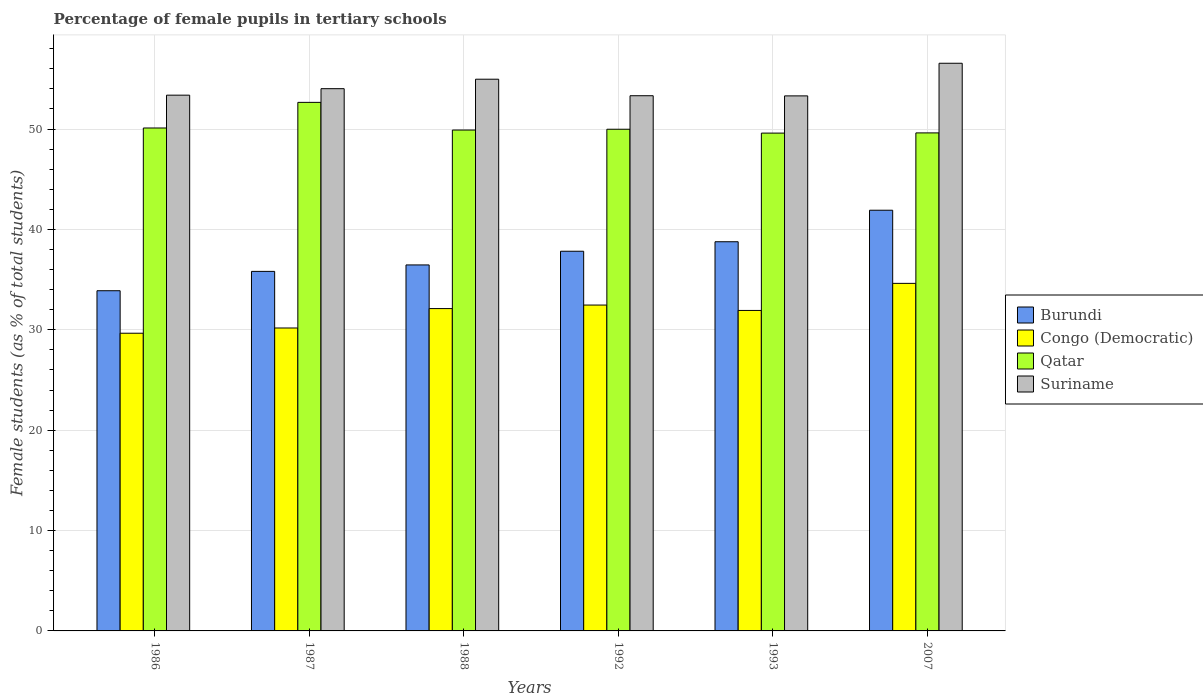How many different coloured bars are there?
Your answer should be compact. 4. How many groups of bars are there?
Your answer should be compact. 6. Are the number of bars per tick equal to the number of legend labels?
Make the answer very short. Yes. How many bars are there on the 6th tick from the right?
Your response must be concise. 4. What is the label of the 4th group of bars from the left?
Keep it short and to the point. 1992. What is the percentage of female pupils in tertiary schools in Suriname in 2007?
Your answer should be compact. 56.55. Across all years, what is the maximum percentage of female pupils in tertiary schools in Congo (Democratic)?
Your answer should be compact. 34.62. Across all years, what is the minimum percentage of female pupils in tertiary schools in Qatar?
Make the answer very short. 49.59. In which year was the percentage of female pupils in tertiary schools in Qatar maximum?
Offer a very short reply. 1987. What is the total percentage of female pupils in tertiary schools in Burundi in the graph?
Make the answer very short. 224.67. What is the difference between the percentage of female pupils in tertiary schools in Burundi in 1987 and that in 1992?
Offer a terse response. -2.01. What is the difference between the percentage of female pupils in tertiary schools in Burundi in 2007 and the percentage of female pupils in tertiary schools in Qatar in 1993?
Ensure brevity in your answer.  -7.68. What is the average percentage of female pupils in tertiary schools in Congo (Democratic) per year?
Make the answer very short. 31.83. In the year 1988, what is the difference between the percentage of female pupils in tertiary schools in Suriname and percentage of female pupils in tertiary schools in Qatar?
Offer a very short reply. 5.06. What is the ratio of the percentage of female pupils in tertiary schools in Congo (Democratic) in 1992 to that in 1993?
Your response must be concise. 1.02. What is the difference between the highest and the second highest percentage of female pupils in tertiary schools in Congo (Democratic)?
Your response must be concise. 2.16. What is the difference between the highest and the lowest percentage of female pupils in tertiary schools in Qatar?
Keep it short and to the point. 3.06. In how many years, is the percentage of female pupils in tertiary schools in Suriname greater than the average percentage of female pupils in tertiary schools in Suriname taken over all years?
Give a very brief answer. 2. Is it the case that in every year, the sum of the percentage of female pupils in tertiary schools in Burundi and percentage of female pupils in tertiary schools in Suriname is greater than the sum of percentage of female pupils in tertiary schools in Qatar and percentage of female pupils in tertiary schools in Congo (Democratic)?
Offer a very short reply. No. What does the 2nd bar from the left in 1987 represents?
Make the answer very short. Congo (Democratic). What does the 4th bar from the right in 1993 represents?
Your answer should be very brief. Burundi. What is the difference between two consecutive major ticks on the Y-axis?
Provide a succinct answer. 10. Does the graph contain any zero values?
Offer a very short reply. No. Where does the legend appear in the graph?
Give a very brief answer. Center right. How many legend labels are there?
Your answer should be compact. 4. What is the title of the graph?
Provide a succinct answer. Percentage of female pupils in tertiary schools. Does "Tonga" appear as one of the legend labels in the graph?
Offer a very short reply. No. What is the label or title of the Y-axis?
Give a very brief answer. Female students (as % of total students). What is the Female students (as % of total students) of Burundi in 1986?
Offer a terse response. 33.89. What is the Female students (as % of total students) in Congo (Democratic) in 1986?
Give a very brief answer. 29.66. What is the Female students (as % of total students) of Qatar in 1986?
Your response must be concise. 50.1. What is the Female students (as % of total students) in Suriname in 1986?
Provide a succinct answer. 53.37. What is the Female students (as % of total students) of Burundi in 1987?
Your answer should be compact. 35.82. What is the Female students (as % of total students) in Congo (Democratic) in 1987?
Give a very brief answer. 30.18. What is the Female students (as % of total students) in Qatar in 1987?
Give a very brief answer. 52.66. What is the Female students (as % of total students) of Suriname in 1987?
Give a very brief answer. 54.02. What is the Female students (as % of total students) of Burundi in 1988?
Your answer should be very brief. 36.46. What is the Female students (as % of total students) of Congo (Democratic) in 1988?
Offer a very short reply. 32.11. What is the Female students (as % of total students) of Qatar in 1988?
Make the answer very short. 49.9. What is the Female students (as % of total students) in Suriname in 1988?
Make the answer very short. 54.96. What is the Female students (as % of total students) of Burundi in 1992?
Give a very brief answer. 37.82. What is the Female students (as % of total students) in Congo (Democratic) in 1992?
Provide a short and direct response. 32.46. What is the Female students (as % of total students) of Qatar in 1992?
Keep it short and to the point. 49.98. What is the Female students (as % of total students) in Suriname in 1992?
Provide a succinct answer. 53.32. What is the Female students (as % of total students) of Burundi in 1993?
Keep it short and to the point. 38.77. What is the Female students (as % of total students) in Congo (Democratic) in 1993?
Offer a terse response. 31.93. What is the Female students (as % of total students) of Qatar in 1993?
Your answer should be compact. 49.59. What is the Female students (as % of total students) of Suriname in 1993?
Your answer should be compact. 53.3. What is the Female students (as % of total students) of Burundi in 2007?
Your response must be concise. 41.91. What is the Female students (as % of total students) of Congo (Democratic) in 2007?
Provide a short and direct response. 34.62. What is the Female students (as % of total students) of Qatar in 2007?
Make the answer very short. 49.61. What is the Female students (as % of total students) of Suriname in 2007?
Provide a short and direct response. 56.55. Across all years, what is the maximum Female students (as % of total students) in Burundi?
Offer a terse response. 41.91. Across all years, what is the maximum Female students (as % of total students) in Congo (Democratic)?
Offer a very short reply. 34.62. Across all years, what is the maximum Female students (as % of total students) in Qatar?
Give a very brief answer. 52.66. Across all years, what is the maximum Female students (as % of total students) of Suriname?
Ensure brevity in your answer.  56.55. Across all years, what is the minimum Female students (as % of total students) of Burundi?
Your response must be concise. 33.89. Across all years, what is the minimum Female students (as % of total students) in Congo (Democratic)?
Your response must be concise. 29.66. Across all years, what is the minimum Female students (as % of total students) in Qatar?
Your answer should be compact. 49.59. Across all years, what is the minimum Female students (as % of total students) in Suriname?
Make the answer very short. 53.3. What is the total Female students (as % of total students) in Burundi in the graph?
Keep it short and to the point. 224.67. What is the total Female students (as % of total students) in Congo (Democratic) in the graph?
Offer a terse response. 190.96. What is the total Female students (as % of total students) of Qatar in the graph?
Ensure brevity in your answer.  301.84. What is the total Female students (as % of total students) of Suriname in the graph?
Provide a succinct answer. 325.52. What is the difference between the Female students (as % of total students) in Burundi in 1986 and that in 1987?
Provide a short and direct response. -1.93. What is the difference between the Female students (as % of total students) in Congo (Democratic) in 1986 and that in 1987?
Keep it short and to the point. -0.52. What is the difference between the Female students (as % of total students) in Qatar in 1986 and that in 1987?
Offer a terse response. -2.55. What is the difference between the Female students (as % of total students) of Suriname in 1986 and that in 1987?
Provide a succinct answer. -0.65. What is the difference between the Female students (as % of total students) in Burundi in 1986 and that in 1988?
Keep it short and to the point. -2.57. What is the difference between the Female students (as % of total students) of Congo (Democratic) in 1986 and that in 1988?
Ensure brevity in your answer.  -2.46. What is the difference between the Female students (as % of total students) of Qatar in 1986 and that in 1988?
Your answer should be very brief. 0.2. What is the difference between the Female students (as % of total students) of Suriname in 1986 and that in 1988?
Provide a short and direct response. -1.59. What is the difference between the Female students (as % of total students) of Burundi in 1986 and that in 1992?
Your answer should be very brief. -3.93. What is the difference between the Female students (as % of total students) of Congo (Democratic) in 1986 and that in 1992?
Offer a terse response. -2.81. What is the difference between the Female students (as % of total students) of Qatar in 1986 and that in 1992?
Offer a terse response. 0.12. What is the difference between the Female students (as % of total students) in Suriname in 1986 and that in 1992?
Provide a succinct answer. 0.06. What is the difference between the Female students (as % of total students) in Burundi in 1986 and that in 1993?
Make the answer very short. -4.88. What is the difference between the Female students (as % of total students) in Congo (Democratic) in 1986 and that in 1993?
Your answer should be compact. -2.27. What is the difference between the Female students (as % of total students) of Qatar in 1986 and that in 1993?
Offer a very short reply. 0.51. What is the difference between the Female students (as % of total students) of Suriname in 1986 and that in 1993?
Give a very brief answer. 0.07. What is the difference between the Female students (as % of total students) of Burundi in 1986 and that in 2007?
Ensure brevity in your answer.  -8.02. What is the difference between the Female students (as % of total students) in Congo (Democratic) in 1986 and that in 2007?
Provide a succinct answer. -4.97. What is the difference between the Female students (as % of total students) in Qatar in 1986 and that in 2007?
Your response must be concise. 0.49. What is the difference between the Female students (as % of total students) in Suriname in 1986 and that in 2007?
Provide a short and direct response. -3.18. What is the difference between the Female students (as % of total students) in Burundi in 1987 and that in 1988?
Offer a terse response. -0.64. What is the difference between the Female students (as % of total students) in Congo (Democratic) in 1987 and that in 1988?
Make the answer very short. -1.93. What is the difference between the Female students (as % of total students) in Qatar in 1987 and that in 1988?
Offer a very short reply. 2.76. What is the difference between the Female students (as % of total students) in Suriname in 1987 and that in 1988?
Give a very brief answer. -0.94. What is the difference between the Female students (as % of total students) in Burundi in 1987 and that in 1992?
Offer a terse response. -2.01. What is the difference between the Female students (as % of total students) in Congo (Democratic) in 1987 and that in 1992?
Your answer should be very brief. -2.29. What is the difference between the Female students (as % of total students) in Qatar in 1987 and that in 1992?
Offer a terse response. 2.68. What is the difference between the Female students (as % of total students) of Suriname in 1987 and that in 1992?
Make the answer very short. 0.7. What is the difference between the Female students (as % of total students) of Burundi in 1987 and that in 1993?
Your answer should be very brief. -2.95. What is the difference between the Female students (as % of total students) in Congo (Democratic) in 1987 and that in 1993?
Provide a succinct answer. -1.75. What is the difference between the Female students (as % of total students) in Qatar in 1987 and that in 1993?
Provide a short and direct response. 3.06. What is the difference between the Female students (as % of total students) of Suriname in 1987 and that in 1993?
Offer a very short reply. 0.72. What is the difference between the Female students (as % of total students) of Burundi in 1987 and that in 2007?
Offer a terse response. -6.09. What is the difference between the Female students (as % of total students) in Congo (Democratic) in 1987 and that in 2007?
Give a very brief answer. -4.45. What is the difference between the Female students (as % of total students) in Qatar in 1987 and that in 2007?
Your response must be concise. 3.04. What is the difference between the Female students (as % of total students) of Suriname in 1987 and that in 2007?
Offer a very short reply. -2.53. What is the difference between the Female students (as % of total students) of Burundi in 1988 and that in 1992?
Provide a succinct answer. -1.36. What is the difference between the Female students (as % of total students) of Congo (Democratic) in 1988 and that in 1992?
Make the answer very short. -0.35. What is the difference between the Female students (as % of total students) of Qatar in 1988 and that in 1992?
Offer a terse response. -0.08. What is the difference between the Female students (as % of total students) in Suriname in 1988 and that in 1992?
Ensure brevity in your answer.  1.65. What is the difference between the Female students (as % of total students) in Burundi in 1988 and that in 1993?
Provide a succinct answer. -2.31. What is the difference between the Female students (as % of total students) of Congo (Democratic) in 1988 and that in 1993?
Your response must be concise. 0.19. What is the difference between the Female students (as % of total students) of Qatar in 1988 and that in 1993?
Provide a succinct answer. 0.31. What is the difference between the Female students (as % of total students) in Suriname in 1988 and that in 1993?
Offer a terse response. 1.66. What is the difference between the Female students (as % of total students) of Burundi in 1988 and that in 2007?
Ensure brevity in your answer.  -5.45. What is the difference between the Female students (as % of total students) of Congo (Democratic) in 1988 and that in 2007?
Offer a very short reply. -2.51. What is the difference between the Female students (as % of total students) of Qatar in 1988 and that in 2007?
Your answer should be very brief. 0.28. What is the difference between the Female students (as % of total students) in Suriname in 1988 and that in 2007?
Ensure brevity in your answer.  -1.59. What is the difference between the Female students (as % of total students) in Burundi in 1992 and that in 1993?
Provide a succinct answer. -0.95. What is the difference between the Female students (as % of total students) of Congo (Democratic) in 1992 and that in 1993?
Give a very brief answer. 0.54. What is the difference between the Female students (as % of total students) of Qatar in 1992 and that in 1993?
Ensure brevity in your answer.  0.38. What is the difference between the Female students (as % of total students) in Suriname in 1992 and that in 1993?
Provide a short and direct response. 0.01. What is the difference between the Female students (as % of total students) in Burundi in 1992 and that in 2007?
Provide a short and direct response. -4.09. What is the difference between the Female students (as % of total students) of Congo (Democratic) in 1992 and that in 2007?
Keep it short and to the point. -2.16. What is the difference between the Female students (as % of total students) in Qatar in 1992 and that in 2007?
Offer a very short reply. 0.36. What is the difference between the Female students (as % of total students) in Suriname in 1992 and that in 2007?
Give a very brief answer. -3.23. What is the difference between the Female students (as % of total students) of Burundi in 1993 and that in 2007?
Your answer should be compact. -3.14. What is the difference between the Female students (as % of total students) of Congo (Democratic) in 1993 and that in 2007?
Your answer should be very brief. -2.7. What is the difference between the Female students (as % of total students) in Qatar in 1993 and that in 2007?
Offer a terse response. -0.02. What is the difference between the Female students (as % of total students) of Suriname in 1993 and that in 2007?
Offer a very short reply. -3.25. What is the difference between the Female students (as % of total students) in Burundi in 1986 and the Female students (as % of total students) in Congo (Democratic) in 1987?
Provide a succinct answer. 3.71. What is the difference between the Female students (as % of total students) in Burundi in 1986 and the Female students (as % of total students) in Qatar in 1987?
Offer a very short reply. -18.76. What is the difference between the Female students (as % of total students) of Burundi in 1986 and the Female students (as % of total students) of Suriname in 1987?
Make the answer very short. -20.13. What is the difference between the Female students (as % of total students) in Congo (Democratic) in 1986 and the Female students (as % of total students) in Qatar in 1987?
Make the answer very short. -23. What is the difference between the Female students (as % of total students) in Congo (Democratic) in 1986 and the Female students (as % of total students) in Suriname in 1987?
Give a very brief answer. -24.36. What is the difference between the Female students (as % of total students) in Qatar in 1986 and the Female students (as % of total students) in Suriname in 1987?
Give a very brief answer. -3.92. What is the difference between the Female students (as % of total students) in Burundi in 1986 and the Female students (as % of total students) in Congo (Democratic) in 1988?
Make the answer very short. 1.78. What is the difference between the Female students (as % of total students) of Burundi in 1986 and the Female students (as % of total students) of Qatar in 1988?
Your answer should be compact. -16.01. What is the difference between the Female students (as % of total students) in Burundi in 1986 and the Female students (as % of total students) in Suriname in 1988?
Your response must be concise. -21.07. What is the difference between the Female students (as % of total students) of Congo (Democratic) in 1986 and the Female students (as % of total students) of Qatar in 1988?
Ensure brevity in your answer.  -20.24. What is the difference between the Female students (as % of total students) in Congo (Democratic) in 1986 and the Female students (as % of total students) in Suriname in 1988?
Provide a short and direct response. -25.31. What is the difference between the Female students (as % of total students) of Qatar in 1986 and the Female students (as % of total students) of Suriname in 1988?
Your answer should be compact. -4.86. What is the difference between the Female students (as % of total students) in Burundi in 1986 and the Female students (as % of total students) in Congo (Democratic) in 1992?
Offer a terse response. 1.43. What is the difference between the Female students (as % of total students) in Burundi in 1986 and the Female students (as % of total students) in Qatar in 1992?
Provide a short and direct response. -16.09. What is the difference between the Female students (as % of total students) of Burundi in 1986 and the Female students (as % of total students) of Suriname in 1992?
Give a very brief answer. -19.43. What is the difference between the Female students (as % of total students) in Congo (Democratic) in 1986 and the Female students (as % of total students) in Qatar in 1992?
Provide a short and direct response. -20.32. What is the difference between the Female students (as % of total students) of Congo (Democratic) in 1986 and the Female students (as % of total students) of Suriname in 1992?
Your response must be concise. -23.66. What is the difference between the Female students (as % of total students) of Qatar in 1986 and the Female students (as % of total students) of Suriname in 1992?
Give a very brief answer. -3.21. What is the difference between the Female students (as % of total students) in Burundi in 1986 and the Female students (as % of total students) in Congo (Democratic) in 1993?
Your answer should be very brief. 1.96. What is the difference between the Female students (as % of total students) in Burundi in 1986 and the Female students (as % of total students) in Qatar in 1993?
Offer a terse response. -15.7. What is the difference between the Female students (as % of total students) of Burundi in 1986 and the Female students (as % of total students) of Suriname in 1993?
Ensure brevity in your answer.  -19.41. What is the difference between the Female students (as % of total students) in Congo (Democratic) in 1986 and the Female students (as % of total students) in Qatar in 1993?
Your response must be concise. -19.94. What is the difference between the Female students (as % of total students) in Congo (Democratic) in 1986 and the Female students (as % of total students) in Suriname in 1993?
Provide a short and direct response. -23.64. What is the difference between the Female students (as % of total students) of Qatar in 1986 and the Female students (as % of total students) of Suriname in 1993?
Your response must be concise. -3.2. What is the difference between the Female students (as % of total students) of Burundi in 1986 and the Female students (as % of total students) of Congo (Democratic) in 2007?
Make the answer very short. -0.73. What is the difference between the Female students (as % of total students) of Burundi in 1986 and the Female students (as % of total students) of Qatar in 2007?
Make the answer very short. -15.72. What is the difference between the Female students (as % of total students) of Burundi in 1986 and the Female students (as % of total students) of Suriname in 2007?
Provide a short and direct response. -22.66. What is the difference between the Female students (as % of total students) in Congo (Democratic) in 1986 and the Female students (as % of total students) in Qatar in 2007?
Ensure brevity in your answer.  -19.96. What is the difference between the Female students (as % of total students) in Congo (Democratic) in 1986 and the Female students (as % of total students) in Suriname in 2007?
Give a very brief answer. -26.89. What is the difference between the Female students (as % of total students) of Qatar in 1986 and the Female students (as % of total students) of Suriname in 2007?
Keep it short and to the point. -6.45. What is the difference between the Female students (as % of total students) in Burundi in 1987 and the Female students (as % of total students) in Congo (Democratic) in 1988?
Provide a succinct answer. 3.71. What is the difference between the Female students (as % of total students) of Burundi in 1987 and the Female students (as % of total students) of Qatar in 1988?
Ensure brevity in your answer.  -14.08. What is the difference between the Female students (as % of total students) of Burundi in 1987 and the Female students (as % of total students) of Suriname in 1988?
Give a very brief answer. -19.14. What is the difference between the Female students (as % of total students) in Congo (Democratic) in 1987 and the Female students (as % of total students) in Qatar in 1988?
Provide a short and direct response. -19.72. What is the difference between the Female students (as % of total students) in Congo (Democratic) in 1987 and the Female students (as % of total students) in Suriname in 1988?
Offer a terse response. -24.79. What is the difference between the Female students (as % of total students) of Qatar in 1987 and the Female students (as % of total students) of Suriname in 1988?
Keep it short and to the point. -2.31. What is the difference between the Female students (as % of total students) in Burundi in 1987 and the Female students (as % of total students) in Congo (Democratic) in 1992?
Offer a terse response. 3.36. What is the difference between the Female students (as % of total students) in Burundi in 1987 and the Female students (as % of total students) in Qatar in 1992?
Provide a succinct answer. -14.16. What is the difference between the Female students (as % of total students) in Burundi in 1987 and the Female students (as % of total students) in Suriname in 1992?
Provide a short and direct response. -17.5. What is the difference between the Female students (as % of total students) of Congo (Democratic) in 1987 and the Female students (as % of total students) of Qatar in 1992?
Ensure brevity in your answer.  -19.8. What is the difference between the Female students (as % of total students) of Congo (Democratic) in 1987 and the Female students (as % of total students) of Suriname in 1992?
Offer a very short reply. -23.14. What is the difference between the Female students (as % of total students) of Qatar in 1987 and the Female students (as % of total students) of Suriname in 1992?
Make the answer very short. -0.66. What is the difference between the Female students (as % of total students) in Burundi in 1987 and the Female students (as % of total students) in Congo (Democratic) in 1993?
Make the answer very short. 3.89. What is the difference between the Female students (as % of total students) of Burundi in 1987 and the Female students (as % of total students) of Qatar in 1993?
Provide a short and direct response. -13.77. What is the difference between the Female students (as % of total students) in Burundi in 1987 and the Female students (as % of total students) in Suriname in 1993?
Provide a succinct answer. -17.48. What is the difference between the Female students (as % of total students) in Congo (Democratic) in 1987 and the Female students (as % of total students) in Qatar in 1993?
Your response must be concise. -19.42. What is the difference between the Female students (as % of total students) in Congo (Democratic) in 1987 and the Female students (as % of total students) in Suriname in 1993?
Make the answer very short. -23.12. What is the difference between the Female students (as % of total students) in Qatar in 1987 and the Female students (as % of total students) in Suriname in 1993?
Ensure brevity in your answer.  -0.65. What is the difference between the Female students (as % of total students) in Burundi in 1987 and the Female students (as % of total students) in Congo (Democratic) in 2007?
Ensure brevity in your answer.  1.2. What is the difference between the Female students (as % of total students) in Burundi in 1987 and the Female students (as % of total students) in Qatar in 2007?
Ensure brevity in your answer.  -13.8. What is the difference between the Female students (as % of total students) in Burundi in 1987 and the Female students (as % of total students) in Suriname in 2007?
Ensure brevity in your answer.  -20.73. What is the difference between the Female students (as % of total students) in Congo (Democratic) in 1987 and the Female students (as % of total students) in Qatar in 2007?
Provide a short and direct response. -19.44. What is the difference between the Female students (as % of total students) of Congo (Democratic) in 1987 and the Female students (as % of total students) of Suriname in 2007?
Provide a short and direct response. -26.37. What is the difference between the Female students (as % of total students) of Qatar in 1987 and the Female students (as % of total students) of Suriname in 2007?
Your answer should be compact. -3.9. What is the difference between the Female students (as % of total students) of Burundi in 1988 and the Female students (as % of total students) of Congo (Democratic) in 1992?
Offer a very short reply. 4. What is the difference between the Female students (as % of total students) of Burundi in 1988 and the Female students (as % of total students) of Qatar in 1992?
Ensure brevity in your answer.  -13.52. What is the difference between the Female students (as % of total students) in Burundi in 1988 and the Female students (as % of total students) in Suriname in 1992?
Provide a short and direct response. -16.86. What is the difference between the Female students (as % of total students) in Congo (Democratic) in 1988 and the Female students (as % of total students) in Qatar in 1992?
Your answer should be compact. -17.87. What is the difference between the Female students (as % of total students) in Congo (Democratic) in 1988 and the Female students (as % of total students) in Suriname in 1992?
Your answer should be compact. -21.2. What is the difference between the Female students (as % of total students) in Qatar in 1988 and the Female students (as % of total students) in Suriname in 1992?
Ensure brevity in your answer.  -3.42. What is the difference between the Female students (as % of total students) in Burundi in 1988 and the Female students (as % of total students) in Congo (Democratic) in 1993?
Provide a succinct answer. 4.53. What is the difference between the Female students (as % of total students) of Burundi in 1988 and the Female students (as % of total students) of Qatar in 1993?
Your answer should be very brief. -13.13. What is the difference between the Female students (as % of total students) in Burundi in 1988 and the Female students (as % of total students) in Suriname in 1993?
Your answer should be very brief. -16.84. What is the difference between the Female students (as % of total students) in Congo (Democratic) in 1988 and the Female students (as % of total students) in Qatar in 1993?
Provide a succinct answer. -17.48. What is the difference between the Female students (as % of total students) in Congo (Democratic) in 1988 and the Female students (as % of total students) in Suriname in 1993?
Provide a succinct answer. -21.19. What is the difference between the Female students (as % of total students) in Qatar in 1988 and the Female students (as % of total students) in Suriname in 1993?
Give a very brief answer. -3.4. What is the difference between the Female students (as % of total students) of Burundi in 1988 and the Female students (as % of total students) of Congo (Democratic) in 2007?
Your answer should be compact. 1.84. What is the difference between the Female students (as % of total students) of Burundi in 1988 and the Female students (as % of total students) of Qatar in 2007?
Provide a short and direct response. -13.15. What is the difference between the Female students (as % of total students) in Burundi in 1988 and the Female students (as % of total students) in Suriname in 2007?
Give a very brief answer. -20.09. What is the difference between the Female students (as % of total students) of Congo (Democratic) in 1988 and the Female students (as % of total students) of Qatar in 2007?
Make the answer very short. -17.5. What is the difference between the Female students (as % of total students) in Congo (Democratic) in 1988 and the Female students (as % of total students) in Suriname in 2007?
Your answer should be very brief. -24.44. What is the difference between the Female students (as % of total students) in Qatar in 1988 and the Female students (as % of total students) in Suriname in 2007?
Offer a terse response. -6.65. What is the difference between the Female students (as % of total students) of Burundi in 1992 and the Female students (as % of total students) of Congo (Democratic) in 1993?
Make the answer very short. 5.9. What is the difference between the Female students (as % of total students) in Burundi in 1992 and the Female students (as % of total students) in Qatar in 1993?
Your answer should be compact. -11.77. What is the difference between the Female students (as % of total students) of Burundi in 1992 and the Female students (as % of total students) of Suriname in 1993?
Ensure brevity in your answer.  -15.48. What is the difference between the Female students (as % of total students) in Congo (Democratic) in 1992 and the Female students (as % of total students) in Qatar in 1993?
Your answer should be compact. -17.13. What is the difference between the Female students (as % of total students) in Congo (Democratic) in 1992 and the Female students (as % of total students) in Suriname in 1993?
Provide a succinct answer. -20.84. What is the difference between the Female students (as % of total students) in Qatar in 1992 and the Female students (as % of total students) in Suriname in 1993?
Offer a very short reply. -3.32. What is the difference between the Female students (as % of total students) of Burundi in 1992 and the Female students (as % of total students) of Congo (Democratic) in 2007?
Keep it short and to the point. 3.2. What is the difference between the Female students (as % of total students) in Burundi in 1992 and the Female students (as % of total students) in Qatar in 2007?
Provide a succinct answer. -11.79. What is the difference between the Female students (as % of total students) of Burundi in 1992 and the Female students (as % of total students) of Suriname in 2007?
Make the answer very short. -18.73. What is the difference between the Female students (as % of total students) in Congo (Democratic) in 1992 and the Female students (as % of total students) in Qatar in 2007?
Give a very brief answer. -17.15. What is the difference between the Female students (as % of total students) in Congo (Democratic) in 1992 and the Female students (as % of total students) in Suriname in 2007?
Make the answer very short. -24.09. What is the difference between the Female students (as % of total students) in Qatar in 1992 and the Female students (as % of total students) in Suriname in 2007?
Give a very brief answer. -6.57. What is the difference between the Female students (as % of total students) in Burundi in 1993 and the Female students (as % of total students) in Congo (Democratic) in 2007?
Provide a succinct answer. 4.15. What is the difference between the Female students (as % of total students) of Burundi in 1993 and the Female students (as % of total students) of Qatar in 2007?
Ensure brevity in your answer.  -10.84. What is the difference between the Female students (as % of total students) of Burundi in 1993 and the Female students (as % of total students) of Suriname in 2007?
Ensure brevity in your answer.  -17.78. What is the difference between the Female students (as % of total students) of Congo (Democratic) in 1993 and the Female students (as % of total students) of Qatar in 2007?
Provide a short and direct response. -17.69. What is the difference between the Female students (as % of total students) in Congo (Democratic) in 1993 and the Female students (as % of total students) in Suriname in 2007?
Your response must be concise. -24.62. What is the difference between the Female students (as % of total students) in Qatar in 1993 and the Female students (as % of total students) in Suriname in 2007?
Offer a very short reply. -6.96. What is the average Female students (as % of total students) in Burundi per year?
Keep it short and to the point. 37.45. What is the average Female students (as % of total students) in Congo (Democratic) per year?
Your response must be concise. 31.83. What is the average Female students (as % of total students) of Qatar per year?
Offer a very short reply. 50.31. What is the average Female students (as % of total students) of Suriname per year?
Offer a terse response. 54.25. In the year 1986, what is the difference between the Female students (as % of total students) in Burundi and Female students (as % of total students) in Congo (Democratic)?
Make the answer very short. 4.23. In the year 1986, what is the difference between the Female students (as % of total students) in Burundi and Female students (as % of total students) in Qatar?
Offer a terse response. -16.21. In the year 1986, what is the difference between the Female students (as % of total students) in Burundi and Female students (as % of total students) in Suriname?
Provide a succinct answer. -19.48. In the year 1986, what is the difference between the Female students (as % of total students) in Congo (Democratic) and Female students (as % of total students) in Qatar?
Ensure brevity in your answer.  -20.45. In the year 1986, what is the difference between the Female students (as % of total students) in Congo (Democratic) and Female students (as % of total students) in Suriname?
Your answer should be compact. -23.72. In the year 1986, what is the difference between the Female students (as % of total students) of Qatar and Female students (as % of total students) of Suriname?
Make the answer very short. -3.27. In the year 1987, what is the difference between the Female students (as % of total students) in Burundi and Female students (as % of total students) in Congo (Democratic)?
Provide a succinct answer. 5.64. In the year 1987, what is the difference between the Female students (as % of total students) in Burundi and Female students (as % of total students) in Qatar?
Make the answer very short. -16.84. In the year 1987, what is the difference between the Female students (as % of total students) of Burundi and Female students (as % of total students) of Suriname?
Keep it short and to the point. -18.2. In the year 1987, what is the difference between the Female students (as % of total students) in Congo (Democratic) and Female students (as % of total students) in Qatar?
Provide a succinct answer. -22.48. In the year 1987, what is the difference between the Female students (as % of total students) in Congo (Democratic) and Female students (as % of total students) in Suriname?
Offer a very short reply. -23.84. In the year 1987, what is the difference between the Female students (as % of total students) in Qatar and Female students (as % of total students) in Suriname?
Keep it short and to the point. -1.36. In the year 1988, what is the difference between the Female students (as % of total students) in Burundi and Female students (as % of total students) in Congo (Democratic)?
Ensure brevity in your answer.  4.35. In the year 1988, what is the difference between the Female students (as % of total students) of Burundi and Female students (as % of total students) of Qatar?
Provide a succinct answer. -13.44. In the year 1988, what is the difference between the Female students (as % of total students) in Burundi and Female students (as % of total students) in Suriname?
Your answer should be very brief. -18.5. In the year 1988, what is the difference between the Female students (as % of total students) in Congo (Democratic) and Female students (as % of total students) in Qatar?
Your answer should be very brief. -17.79. In the year 1988, what is the difference between the Female students (as % of total students) in Congo (Democratic) and Female students (as % of total students) in Suriname?
Ensure brevity in your answer.  -22.85. In the year 1988, what is the difference between the Female students (as % of total students) in Qatar and Female students (as % of total students) in Suriname?
Provide a short and direct response. -5.06. In the year 1992, what is the difference between the Female students (as % of total students) of Burundi and Female students (as % of total students) of Congo (Democratic)?
Offer a terse response. 5.36. In the year 1992, what is the difference between the Female students (as % of total students) of Burundi and Female students (as % of total students) of Qatar?
Your answer should be very brief. -12.15. In the year 1992, what is the difference between the Female students (as % of total students) in Burundi and Female students (as % of total students) in Suriname?
Provide a succinct answer. -15.49. In the year 1992, what is the difference between the Female students (as % of total students) in Congo (Democratic) and Female students (as % of total students) in Qatar?
Offer a terse response. -17.51. In the year 1992, what is the difference between the Female students (as % of total students) of Congo (Democratic) and Female students (as % of total students) of Suriname?
Ensure brevity in your answer.  -20.85. In the year 1992, what is the difference between the Female students (as % of total students) of Qatar and Female students (as % of total students) of Suriname?
Provide a succinct answer. -3.34. In the year 1993, what is the difference between the Female students (as % of total students) in Burundi and Female students (as % of total students) in Congo (Democratic)?
Offer a terse response. 6.84. In the year 1993, what is the difference between the Female students (as % of total students) in Burundi and Female students (as % of total students) in Qatar?
Offer a terse response. -10.82. In the year 1993, what is the difference between the Female students (as % of total students) in Burundi and Female students (as % of total students) in Suriname?
Ensure brevity in your answer.  -14.53. In the year 1993, what is the difference between the Female students (as % of total students) in Congo (Democratic) and Female students (as % of total students) in Qatar?
Offer a terse response. -17.67. In the year 1993, what is the difference between the Female students (as % of total students) of Congo (Democratic) and Female students (as % of total students) of Suriname?
Your answer should be very brief. -21.37. In the year 1993, what is the difference between the Female students (as % of total students) in Qatar and Female students (as % of total students) in Suriname?
Your response must be concise. -3.71. In the year 2007, what is the difference between the Female students (as % of total students) in Burundi and Female students (as % of total students) in Congo (Democratic)?
Make the answer very short. 7.29. In the year 2007, what is the difference between the Female students (as % of total students) of Burundi and Female students (as % of total students) of Qatar?
Offer a very short reply. -7.7. In the year 2007, what is the difference between the Female students (as % of total students) of Burundi and Female students (as % of total students) of Suriname?
Give a very brief answer. -14.64. In the year 2007, what is the difference between the Female students (as % of total students) in Congo (Democratic) and Female students (as % of total students) in Qatar?
Offer a terse response. -14.99. In the year 2007, what is the difference between the Female students (as % of total students) in Congo (Democratic) and Female students (as % of total students) in Suriname?
Keep it short and to the point. -21.93. In the year 2007, what is the difference between the Female students (as % of total students) in Qatar and Female students (as % of total students) in Suriname?
Your answer should be compact. -6.94. What is the ratio of the Female students (as % of total students) of Burundi in 1986 to that in 1987?
Make the answer very short. 0.95. What is the ratio of the Female students (as % of total students) of Congo (Democratic) in 1986 to that in 1987?
Your answer should be very brief. 0.98. What is the ratio of the Female students (as % of total students) of Qatar in 1986 to that in 1987?
Provide a short and direct response. 0.95. What is the ratio of the Female students (as % of total students) in Burundi in 1986 to that in 1988?
Offer a terse response. 0.93. What is the ratio of the Female students (as % of total students) in Congo (Democratic) in 1986 to that in 1988?
Give a very brief answer. 0.92. What is the ratio of the Female students (as % of total students) in Suriname in 1986 to that in 1988?
Your answer should be very brief. 0.97. What is the ratio of the Female students (as % of total students) in Burundi in 1986 to that in 1992?
Provide a short and direct response. 0.9. What is the ratio of the Female students (as % of total students) of Congo (Democratic) in 1986 to that in 1992?
Make the answer very short. 0.91. What is the ratio of the Female students (as % of total students) in Burundi in 1986 to that in 1993?
Give a very brief answer. 0.87. What is the ratio of the Female students (as % of total students) in Congo (Democratic) in 1986 to that in 1993?
Keep it short and to the point. 0.93. What is the ratio of the Female students (as % of total students) of Qatar in 1986 to that in 1993?
Your response must be concise. 1.01. What is the ratio of the Female students (as % of total students) of Burundi in 1986 to that in 2007?
Your answer should be compact. 0.81. What is the ratio of the Female students (as % of total students) of Congo (Democratic) in 1986 to that in 2007?
Your answer should be very brief. 0.86. What is the ratio of the Female students (as % of total students) of Qatar in 1986 to that in 2007?
Your answer should be very brief. 1.01. What is the ratio of the Female students (as % of total students) in Suriname in 1986 to that in 2007?
Offer a very short reply. 0.94. What is the ratio of the Female students (as % of total students) in Burundi in 1987 to that in 1988?
Keep it short and to the point. 0.98. What is the ratio of the Female students (as % of total students) in Congo (Democratic) in 1987 to that in 1988?
Your answer should be compact. 0.94. What is the ratio of the Female students (as % of total students) in Qatar in 1987 to that in 1988?
Provide a succinct answer. 1.06. What is the ratio of the Female students (as % of total students) in Suriname in 1987 to that in 1988?
Ensure brevity in your answer.  0.98. What is the ratio of the Female students (as % of total students) of Burundi in 1987 to that in 1992?
Give a very brief answer. 0.95. What is the ratio of the Female students (as % of total students) of Congo (Democratic) in 1987 to that in 1992?
Keep it short and to the point. 0.93. What is the ratio of the Female students (as % of total students) of Qatar in 1987 to that in 1992?
Provide a short and direct response. 1.05. What is the ratio of the Female students (as % of total students) of Suriname in 1987 to that in 1992?
Provide a short and direct response. 1.01. What is the ratio of the Female students (as % of total students) in Burundi in 1987 to that in 1993?
Provide a succinct answer. 0.92. What is the ratio of the Female students (as % of total students) of Congo (Democratic) in 1987 to that in 1993?
Provide a succinct answer. 0.95. What is the ratio of the Female students (as % of total students) in Qatar in 1987 to that in 1993?
Offer a terse response. 1.06. What is the ratio of the Female students (as % of total students) in Suriname in 1987 to that in 1993?
Your response must be concise. 1.01. What is the ratio of the Female students (as % of total students) in Burundi in 1987 to that in 2007?
Your answer should be very brief. 0.85. What is the ratio of the Female students (as % of total students) of Congo (Democratic) in 1987 to that in 2007?
Your answer should be compact. 0.87. What is the ratio of the Female students (as % of total students) in Qatar in 1987 to that in 2007?
Keep it short and to the point. 1.06. What is the ratio of the Female students (as % of total students) of Suriname in 1987 to that in 2007?
Offer a very short reply. 0.96. What is the ratio of the Female students (as % of total students) in Burundi in 1988 to that in 1992?
Make the answer very short. 0.96. What is the ratio of the Female students (as % of total students) of Suriname in 1988 to that in 1992?
Your response must be concise. 1.03. What is the ratio of the Female students (as % of total students) of Burundi in 1988 to that in 1993?
Offer a very short reply. 0.94. What is the ratio of the Female students (as % of total students) in Congo (Democratic) in 1988 to that in 1993?
Keep it short and to the point. 1.01. What is the ratio of the Female students (as % of total students) of Suriname in 1988 to that in 1993?
Provide a short and direct response. 1.03. What is the ratio of the Female students (as % of total students) in Burundi in 1988 to that in 2007?
Offer a terse response. 0.87. What is the ratio of the Female students (as % of total students) in Congo (Democratic) in 1988 to that in 2007?
Your answer should be compact. 0.93. What is the ratio of the Female students (as % of total students) in Qatar in 1988 to that in 2007?
Your answer should be compact. 1.01. What is the ratio of the Female students (as % of total students) in Suriname in 1988 to that in 2007?
Provide a succinct answer. 0.97. What is the ratio of the Female students (as % of total students) in Burundi in 1992 to that in 1993?
Offer a very short reply. 0.98. What is the ratio of the Female students (as % of total students) in Congo (Democratic) in 1992 to that in 1993?
Make the answer very short. 1.02. What is the ratio of the Female students (as % of total students) in Burundi in 1992 to that in 2007?
Keep it short and to the point. 0.9. What is the ratio of the Female students (as % of total students) of Congo (Democratic) in 1992 to that in 2007?
Offer a terse response. 0.94. What is the ratio of the Female students (as % of total students) in Qatar in 1992 to that in 2007?
Offer a very short reply. 1.01. What is the ratio of the Female students (as % of total students) in Suriname in 1992 to that in 2007?
Offer a terse response. 0.94. What is the ratio of the Female students (as % of total students) of Burundi in 1993 to that in 2007?
Provide a succinct answer. 0.93. What is the ratio of the Female students (as % of total students) in Congo (Democratic) in 1993 to that in 2007?
Offer a very short reply. 0.92. What is the ratio of the Female students (as % of total students) of Qatar in 1993 to that in 2007?
Your answer should be compact. 1. What is the ratio of the Female students (as % of total students) of Suriname in 1993 to that in 2007?
Keep it short and to the point. 0.94. What is the difference between the highest and the second highest Female students (as % of total students) of Burundi?
Offer a terse response. 3.14. What is the difference between the highest and the second highest Female students (as % of total students) of Congo (Democratic)?
Your answer should be very brief. 2.16. What is the difference between the highest and the second highest Female students (as % of total students) in Qatar?
Provide a short and direct response. 2.55. What is the difference between the highest and the second highest Female students (as % of total students) in Suriname?
Make the answer very short. 1.59. What is the difference between the highest and the lowest Female students (as % of total students) of Burundi?
Provide a short and direct response. 8.02. What is the difference between the highest and the lowest Female students (as % of total students) in Congo (Democratic)?
Your response must be concise. 4.97. What is the difference between the highest and the lowest Female students (as % of total students) in Qatar?
Offer a terse response. 3.06. What is the difference between the highest and the lowest Female students (as % of total students) of Suriname?
Give a very brief answer. 3.25. 